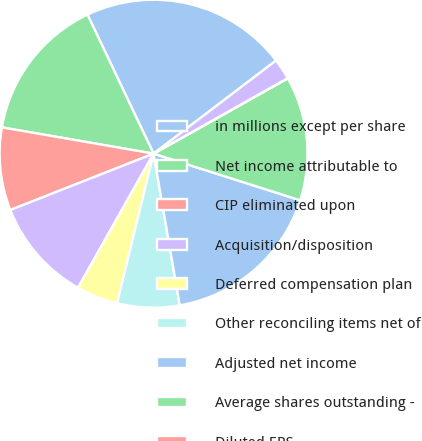Convert chart. <chart><loc_0><loc_0><loc_500><loc_500><pie_chart><fcel>in millions except per share<fcel>Net income attributable to<fcel>CIP eliminated upon<fcel>Acquisition/disposition<fcel>Deferred compensation plan<fcel>Other reconciling items net of<fcel>Adjusted net income<fcel>Average shares outstanding -<fcel>Diluted EPS<fcel>Adjusted diluted EPS<nl><fcel>21.72%<fcel>15.21%<fcel>8.7%<fcel>10.87%<fcel>4.36%<fcel>6.53%<fcel>17.38%<fcel>13.04%<fcel>0.02%<fcel>2.19%<nl></chart> 